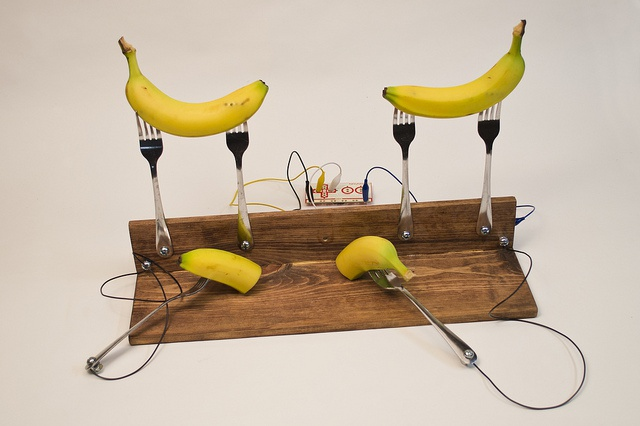Describe the objects in this image and their specific colors. I can see banana in darkgray, gold, and olive tones, banana in darkgray, olive, and gold tones, banana in darkgray, gold, olive, and maroon tones, banana in darkgray, gold, and olive tones, and fork in darkgray, black, gray, and maroon tones in this image. 